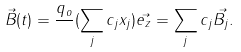<formula> <loc_0><loc_0><loc_500><loc_500>\vec { B } ( t ) = \frac { q _ { o } } { } ( \sum _ { j } c _ { j } x _ { j } ) \vec { e _ { z } } = \sum _ { j } c _ { j } \vec { B _ { j } } .</formula> 